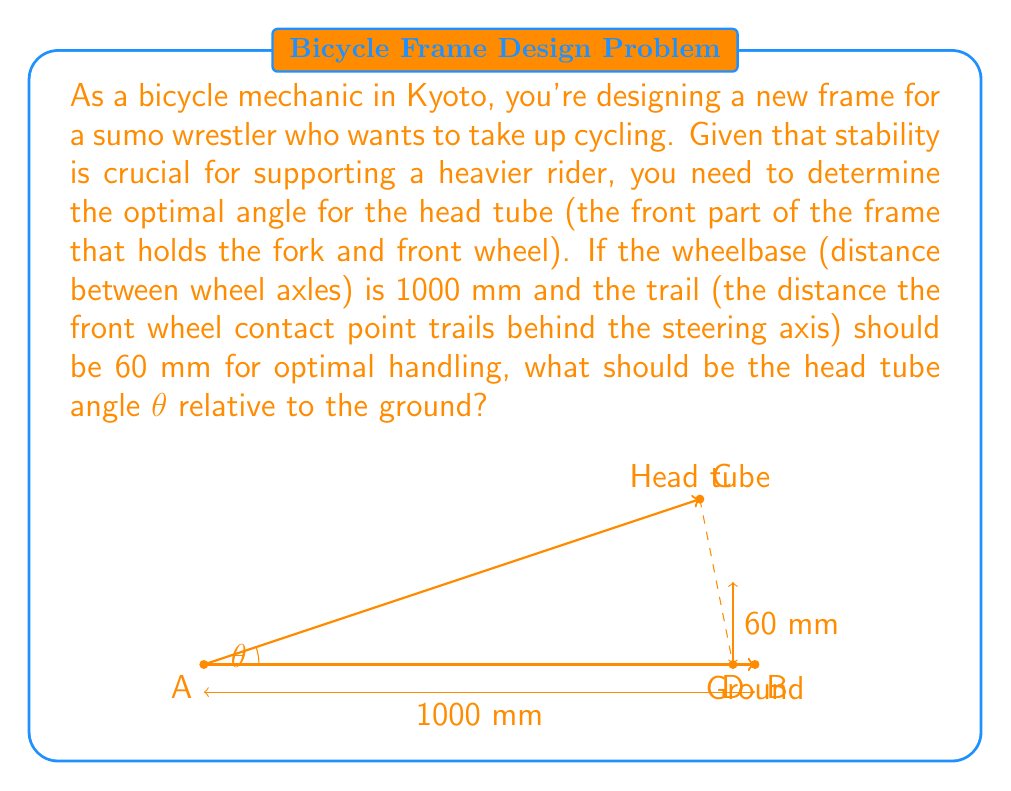Help me with this question. To solve this problem, we'll use trigonometry and the given information:

1) Let's define our variables:
   $\theta$ = head tube angle (what we're solving for)
   $w$ = wheelbase = 1000 mm
   $t$ = trail = 60 mm

2) In the diagram, we can see that the trail forms a right triangle with the head tube and a portion of the wheelbase.

3) The tangent of the head tube angle is equal to the opposite side (trail) divided by the adjacent side (portion of wheelbase):

   $$\tan \theta = \frac{t}{w - x}$$

   where $x$ is the distance from the front wheel to where the head tube would intersect the ground if extended.

4) We can also write:

   $$\tan \theta = \frac{w}{x}$$

5) From these two equations, we can derive:

   $$\frac{t}{w - x} = \frac{w}{x}$$

6) Cross-multiplying:

   $$tx = w(w - x)$$
   $$tx = w^2 - wx$$

7) Rearranging:

   $$w^2 = wx + tx$$
   $$w^2 = x(w + t)$$

8) Solving for $x$:

   $$x = \frac{w^2}{w + t} = \frac{1000^2}{1000 + 60} \approx 943.40 \text{ mm}$$

9) Now we can find $\theta$ using the arctangent function:

   $$\theta = \arctan(\frac{t}{w - x}) = \arctan(\frac{60}{1000 - 943.40})$$

10) Calculating the final result:

    $$\theta = \arctan(\frac{60}{56.60}) \approx 46.69°$$
Answer: The optimal head tube angle $\theta$ is approximately $46.69°$ relative to the ground. 